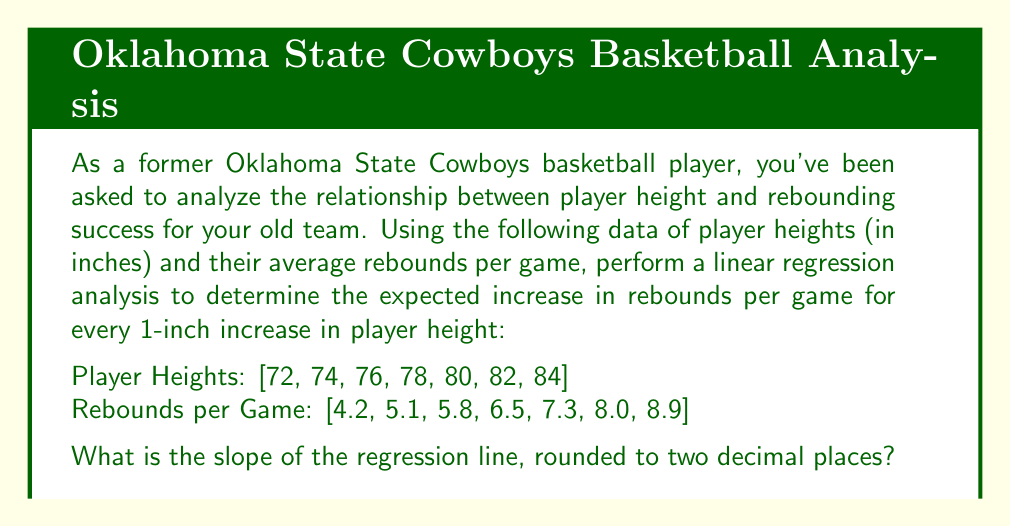What is the answer to this math problem? To perform linear regression analysis, we'll follow these steps:

1) First, let's calculate the means of X (height) and Y (rebounds):

   $\bar{X} = \frac{72 + 74 + 76 + 78 + 80 + 82 + 84}{7} = 78$
   $\bar{Y} = \frac{4.2 + 5.1 + 5.8 + 6.5 + 7.3 + 8.0 + 8.9}{7} = 6.54$

2) Now, we'll calculate $\sum (X - \bar{X})(Y - \bar{Y})$ and $\sum (X - \bar{X})^2$:

   $\sum (X - \bar{X})(Y - \bar{Y}) = (-6)(-2.34) + (-4)(-1.44) + ... + (6)(2.36) = 168$
   $\sum (X - \bar{X})^2 = (-6)^2 + (-4)^2 + ... + (6)^2 = 140$

3) The slope of the regression line is given by:

   $$b = \frac{\sum (X - \bar{X})(Y - \bar{Y})}{\sum (X - \bar{X})^2}$$

4) Substituting our calculated values:

   $$b = \frac{168}{140} = 1.2$$

5) Rounding to two decimal places:

   $b = 1.20$

This slope indicates that for every 1-inch increase in player height, we expect an increase of 1.20 rebounds per game on average.
Answer: 1.20 